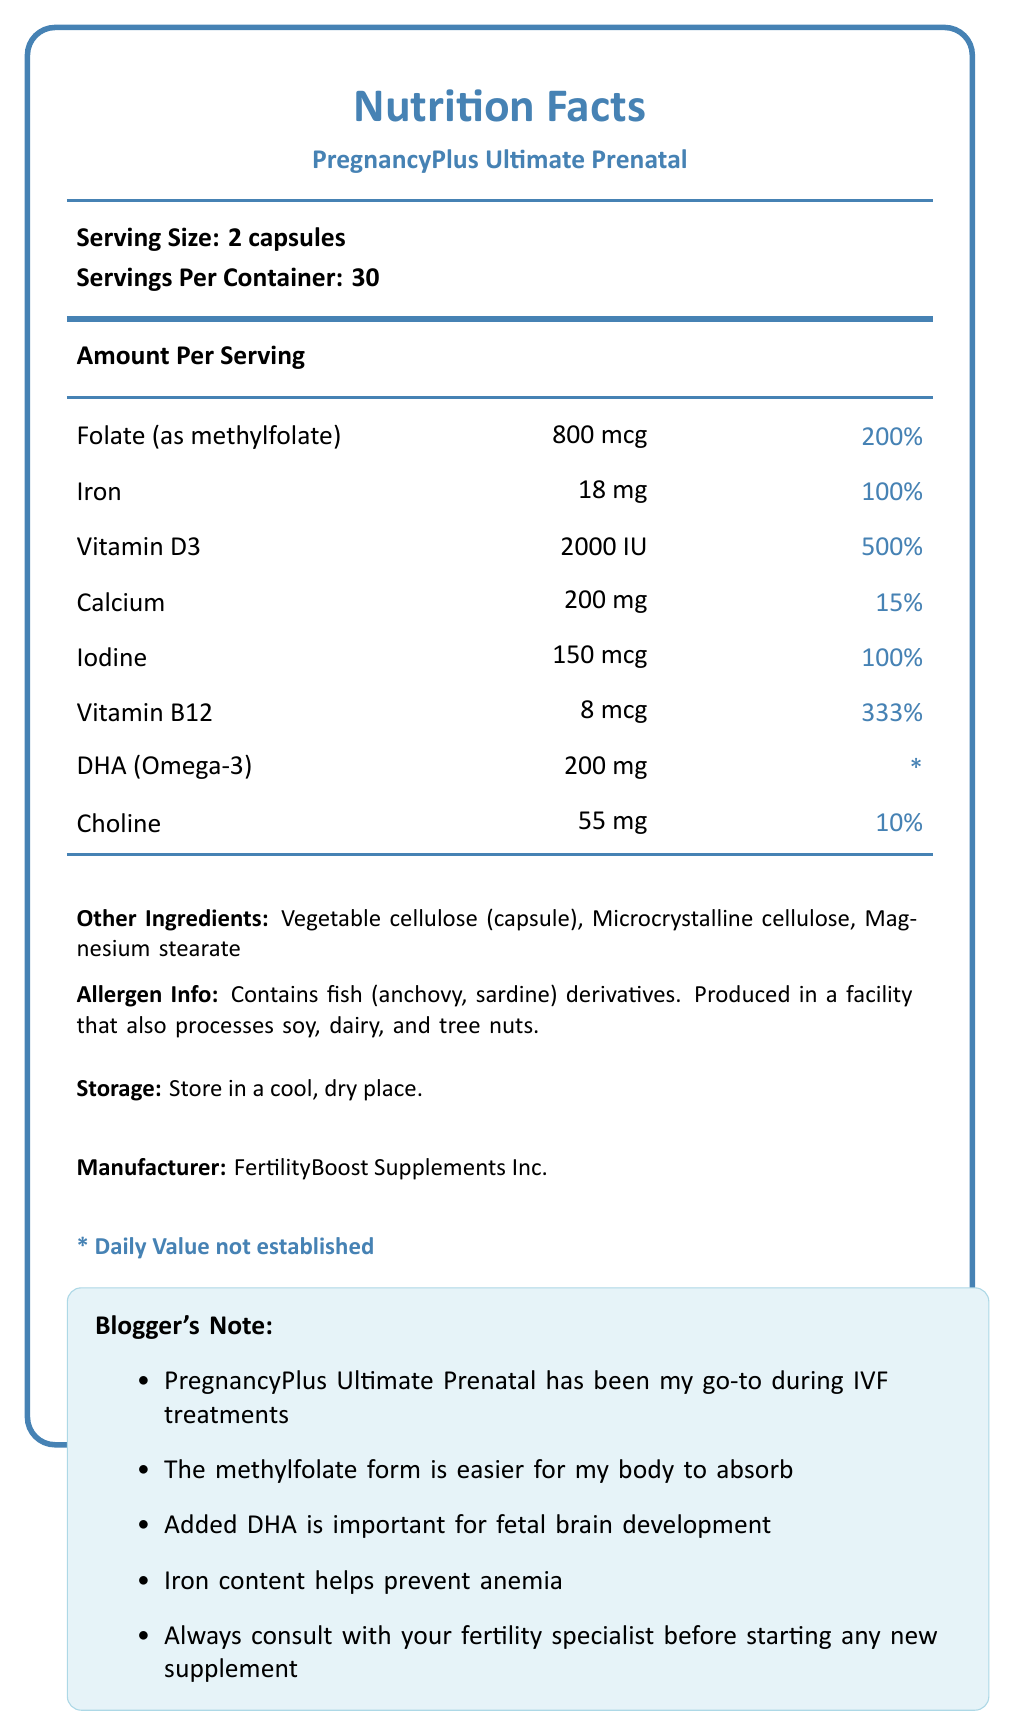which product do the Nutrition Facts pertain to? The title and several nodes specify that the Nutrition Facts label pertains to the PregnancyPlus Ultimate Prenatal supplement.
Answer: PregnancyPlus Ultimate Prenatal what is the serving size? Located towards the top of the Nutrition Facts label under the title.
Answer: 2 capsules how much folate does each serving provide? Listed under the Amount Per Serving section and next to Folate (as methylfolate).
Answer: 800 mcg what percentage of the daily value of vitamin D3 is provided in each serving? Listed under the Amount Per Serving section and next to Vitamin D3.
Answer: 500% what are the other ingredients listed in the product? Mentioned in the lower section of the document under Other Ingredients.
Answer: Vegetable cellulose (capsule), Microcrystalline cellulose, Magnesium stearate which vitamin has the highest daily value percentage in this prenatal supplement? A. Iron B. Vitamin D3 C. Vitamin B12 Vitamin D3 has a daily value percentage of 500%, which is the highest among the listed nutrients.
Answer: B what is the common concern during pregnancy that the iron content in this supplement helps prevent? A. Osteoporosis B. Anemia C. Hypertension D. Nausea The bloggler's notes mention that the iron content helps prevent anemia during pregnancy and fertility treatments.
Answer: B does this document indicate if the supplement contains dairy? According to the Allergen Info, the supplement is produced in a facility that also processes dairy.
Answer: Yes can you determine the total amount of vitamin A in this supplement? The document does not provide any information regarding the amount of vitamin A in the supplement.
Answer: Cannot be determined summarize the main information provided in the document The summary encapsulates the main sections and information components, detailing the specific nutrients, additional ingredient information, and comparative analysis with other products as well as personal usage notes.
Answer: This document provides the Nutrition Facts of the PregnancyPlus Ultimate Prenatal supplement, including serving size, servings per container, key nutrients with their amounts and daily value percentages, other ingredients, allergen information, storage instructions, and manufacturer details. It also highlights comparisons with other prenatal supplements and includes personal notes from a blogger who focuses on infertility treatments. 